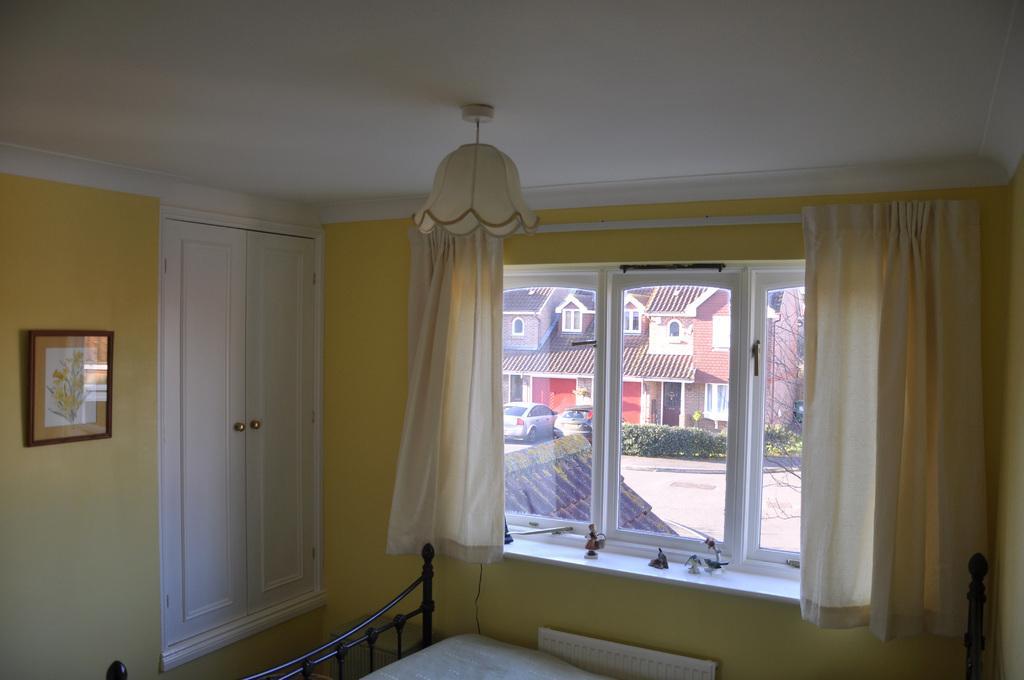Could you give a brief overview of what you see in this image? In this image we can see curtains, windows, photo frames, light, bed. In the background we can see houses, cars, plants, tree and road. 